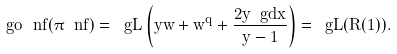<formula> <loc_0><loc_0><loc_500><loc_500>\ g o _ { \ } n f ( \pi _ { \ } n f ) = \ g L \left ( y w + w ^ { q } + \frac { 2 y \ g d x } { y - 1 } \right ) = \ g L ( R ( 1 ) ) .</formula> 